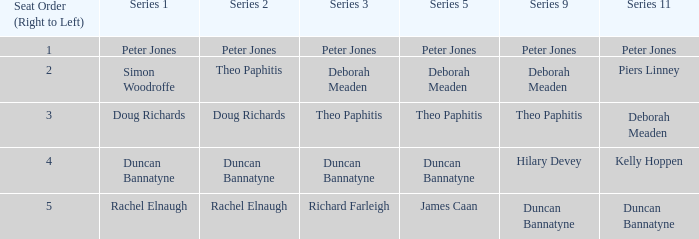What is the count of seat orders in a series 3 with deborah meaden, organized from right to left? 1.0. 